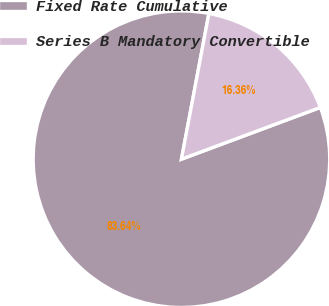Convert chart to OTSL. <chart><loc_0><loc_0><loc_500><loc_500><pie_chart><fcel>Fixed Rate Cumulative<fcel>Series B Mandatory Convertible<nl><fcel>83.64%<fcel>16.36%<nl></chart> 